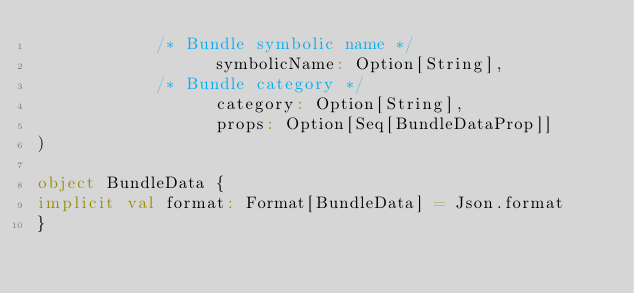<code> <loc_0><loc_0><loc_500><loc_500><_Scala_>            /* Bundle symbolic name */
                  symbolicName: Option[String],
            /* Bundle category */
                  category: Option[String],
                  props: Option[Seq[BundleDataProp]]
)

object BundleData {
implicit val format: Format[BundleData] = Json.format
}

</code> 